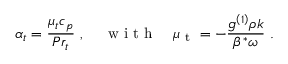<formula> <loc_0><loc_0><loc_500><loc_500>\alpha _ { t } = \frac { { { \mu _ { t } } { c _ { p } } } } { { P { r _ { t } } } } , \quad w i t h \quad \mu _ { t } = - \frac { { { g ^ { \left ( 1 \right ) } } \rho k } } { { { \beta ^ { * } } \omega } } .</formula> 